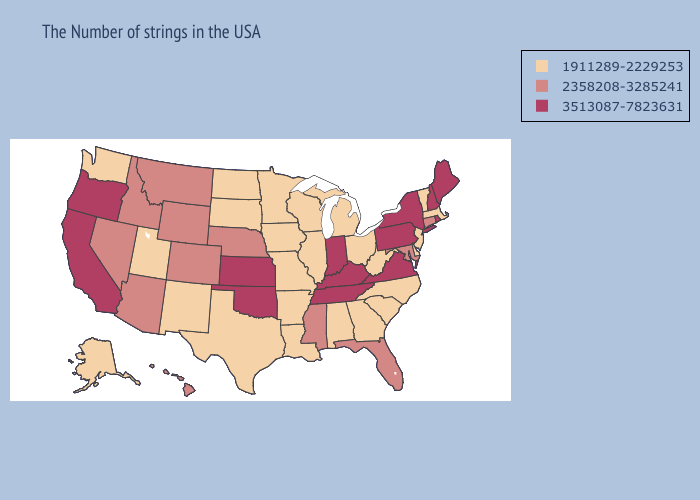Which states have the lowest value in the USA?
Answer briefly. Massachusetts, Vermont, New Jersey, Delaware, North Carolina, South Carolina, West Virginia, Ohio, Georgia, Michigan, Alabama, Wisconsin, Illinois, Louisiana, Missouri, Arkansas, Minnesota, Iowa, Texas, South Dakota, North Dakota, New Mexico, Utah, Washington, Alaska. Does Nebraska have a higher value than Arizona?
Answer briefly. No. Does Nebraska have the lowest value in the USA?
Quick response, please. No. Name the states that have a value in the range 2358208-3285241?
Answer briefly. Connecticut, Maryland, Florida, Mississippi, Nebraska, Wyoming, Colorado, Montana, Arizona, Idaho, Nevada, Hawaii. What is the lowest value in the USA?
Keep it brief. 1911289-2229253. Name the states that have a value in the range 1911289-2229253?
Write a very short answer. Massachusetts, Vermont, New Jersey, Delaware, North Carolina, South Carolina, West Virginia, Ohio, Georgia, Michigan, Alabama, Wisconsin, Illinois, Louisiana, Missouri, Arkansas, Minnesota, Iowa, Texas, South Dakota, North Dakota, New Mexico, Utah, Washington, Alaska. Among the states that border Georgia , does North Carolina have the highest value?
Answer briefly. No. What is the value of Wyoming?
Short answer required. 2358208-3285241. What is the value of Rhode Island?
Be succinct. 3513087-7823631. Which states hav the highest value in the West?
Short answer required. California, Oregon. What is the value of New Hampshire?
Be succinct. 3513087-7823631. Which states have the lowest value in the West?
Answer briefly. New Mexico, Utah, Washington, Alaska. Does Indiana have the lowest value in the MidWest?
Concise answer only. No. Among the states that border Colorado , which have the highest value?
Give a very brief answer. Kansas, Oklahoma. 